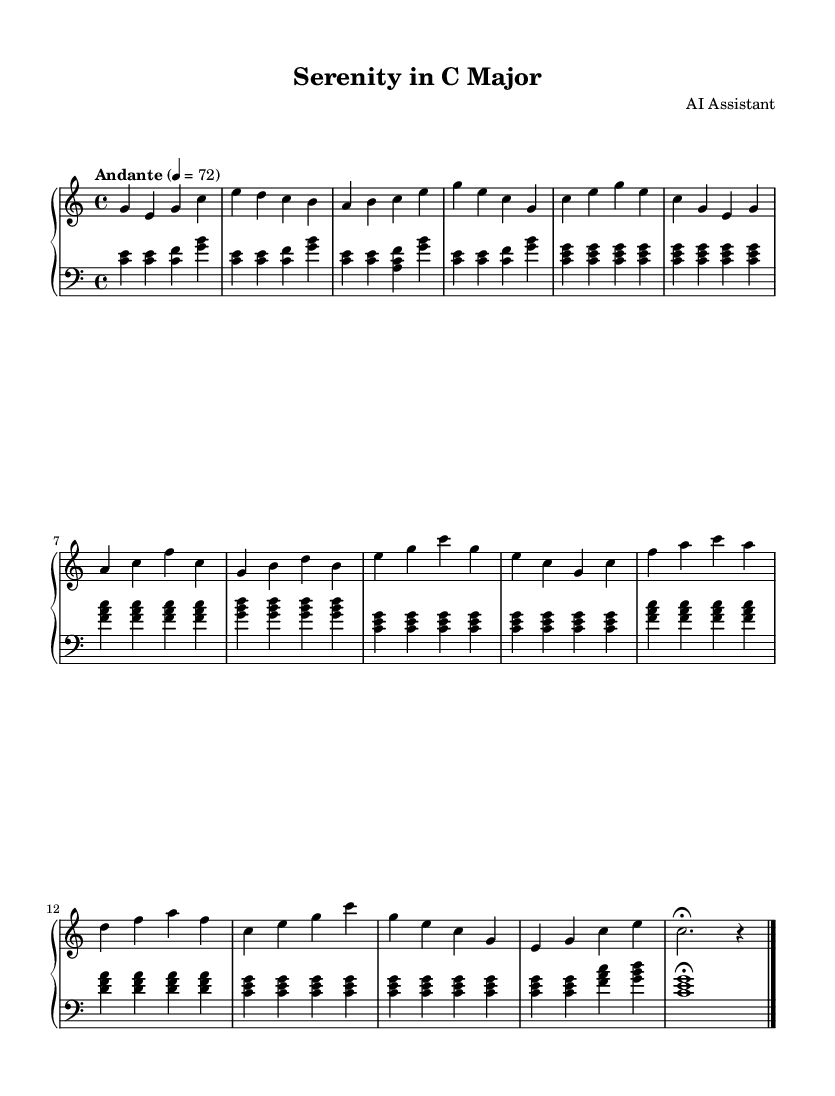What is the key signature of this music? The key signature is indicated at the beginning of the staff. It shows no sharps or flats, which corresponds to C major.
Answer: C major What is the time signature of this music? The time signature is displayed at the beginning, which is 4 over 4, meaning there are four beats in a measure and the quarter note gets one beat.
Answer: 4/4 What is the tempo marking? The tempo marking is found at the start of the piece, indicating a speed of 72 beats per minute with a description of "Andante," suggesting a moderate pace.
Answer: Andante 4 = 72 How many measures are there in the introduction section? The introduction is made up of 4 measures of music, which can be counted visually in the left-hand and right-hand parts.
Answer: 4 measures What is the final note in the coda section? The coda ends with a fermata, indicated by a symbol that extends the last note; in this case, it is a quarter note C, which holds longer than usual.
Answer: C Which theme appears first in the piece? By analyzing the sections, Theme A is the first theme introduced after the introduction, consisting of specific musical phrases in the notation.
Answer: Theme A What is the composer’s name listed in the music? The composer's name is indicated in the header section of the sheet music, which states "AI Assistant" as the composer.
Answer: AI Assistant 